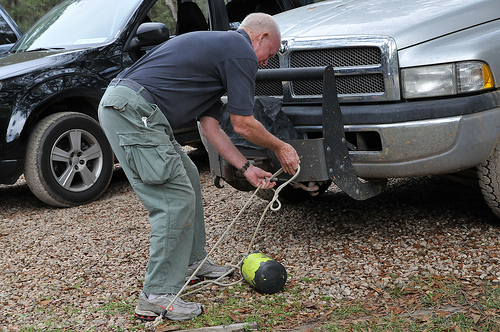What vehicle is to the right of the man? The silver truck occupies the right side of the man as seen in the image. 